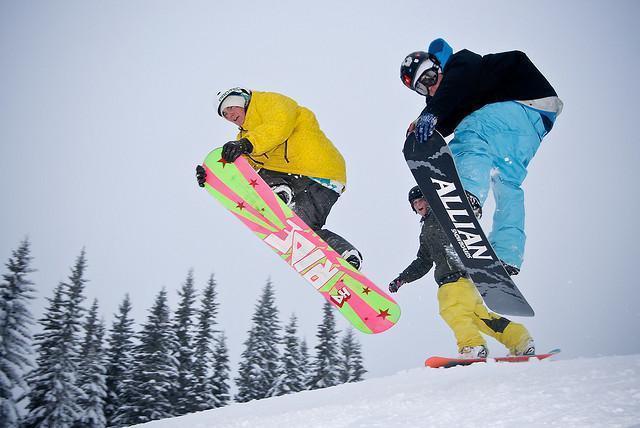What have these children likely practiced?
Pick the right solution, then justify: 'Answer: answer
Rationale: rationale.'
Options: Boxing, sprinting, skiing, swimming. Answer: skiing.
Rationale: These children are likely skiing. 